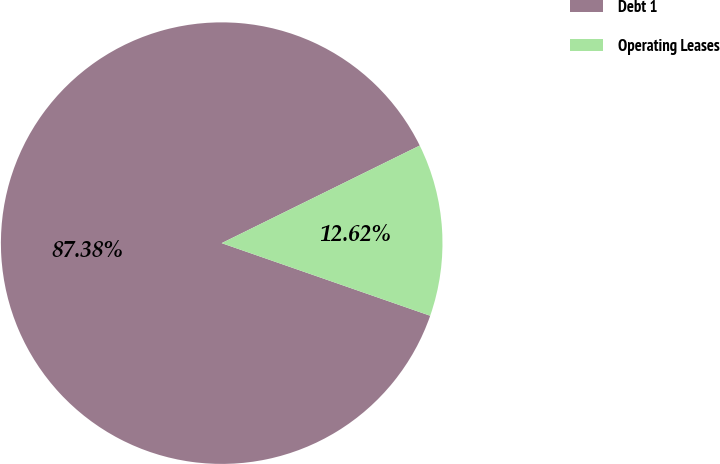Convert chart. <chart><loc_0><loc_0><loc_500><loc_500><pie_chart><fcel>Debt 1<fcel>Operating Leases<nl><fcel>87.38%<fcel>12.62%<nl></chart> 